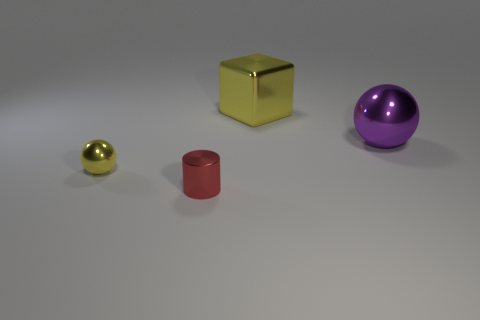Subtract all blue spheres. Subtract all purple cylinders. How many spheres are left? 2 Add 1 rubber balls. How many objects exist? 5 Subtract all cubes. How many objects are left? 3 Add 1 yellow objects. How many yellow objects are left? 3 Add 3 red objects. How many red objects exist? 4 Subtract 0 green blocks. How many objects are left? 4 Subtract all small red cylinders. Subtract all yellow metallic balls. How many objects are left? 2 